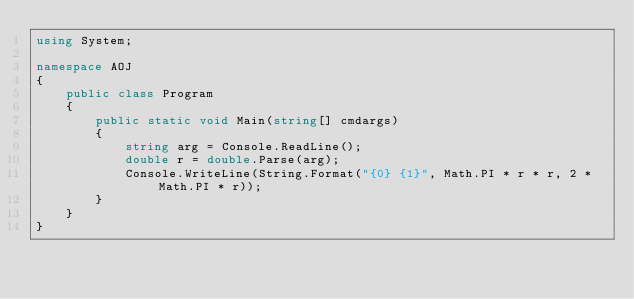Convert code to text. <code><loc_0><loc_0><loc_500><loc_500><_C#_>using System;

namespace AOJ
{
    public class Program
    {
        public static void Main(string[] cmdargs)
        {
            string arg = Console.ReadLine();
            double r = double.Parse(arg);
            Console.WriteLine(String.Format("{0} {1}", Math.PI * r * r, 2 * Math.PI * r));
        }
    }
}</code> 